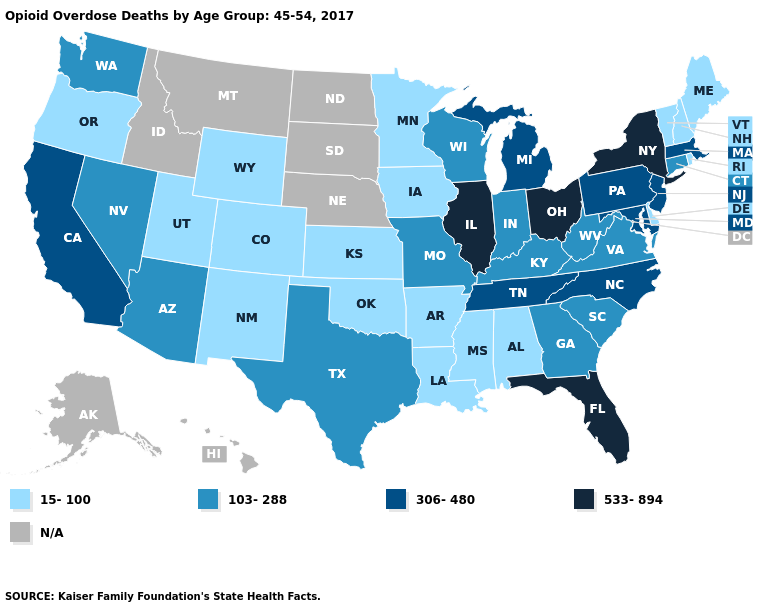Which states have the lowest value in the USA?
Be succinct. Alabama, Arkansas, Colorado, Delaware, Iowa, Kansas, Louisiana, Maine, Minnesota, Mississippi, New Hampshire, New Mexico, Oklahoma, Oregon, Rhode Island, Utah, Vermont, Wyoming. Among the states that border Nevada , which have the lowest value?
Give a very brief answer. Oregon, Utah. What is the value of Nevada?
Concise answer only. 103-288. What is the lowest value in the USA?
Give a very brief answer. 15-100. What is the value of South Dakota?
Answer briefly. N/A. What is the value of Wyoming?
Give a very brief answer. 15-100. Name the states that have a value in the range 15-100?
Be succinct. Alabama, Arkansas, Colorado, Delaware, Iowa, Kansas, Louisiana, Maine, Minnesota, Mississippi, New Hampshire, New Mexico, Oklahoma, Oregon, Rhode Island, Utah, Vermont, Wyoming. Name the states that have a value in the range 15-100?
Give a very brief answer. Alabama, Arkansas, Colorado, Delaware, Iowa, Kansas, Louisiana, Maine, Minnesota, Mississippi, New Hampshire, New Mexico, Oklahoma, Oregon, Rhode Island, Utah, Vermont, Wyoming. Does the first symbol in the legend represent the smallest category?
Answer briefly. Yes. Which states have the highest value in the USA?
Write a very short answer. Florida, Illinois, New York, Ohio. Does New York have the highest value in the Northeast?
Answer briefly. Yes. Among the states that border Georgia , does Alabama have the lowest value?
Keep it brief. Yes. 